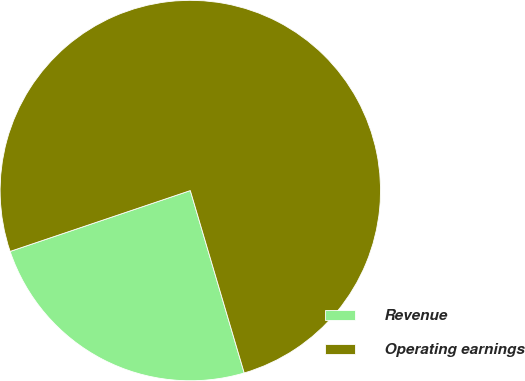Convert chart. <chart><loc_0><loc_0><loc_500><loc_500><pie_chart><fcel>Revenue<fcel>Operating earnings<nl><fcel>24.39%<fcel>75.61%<nl></chart> 